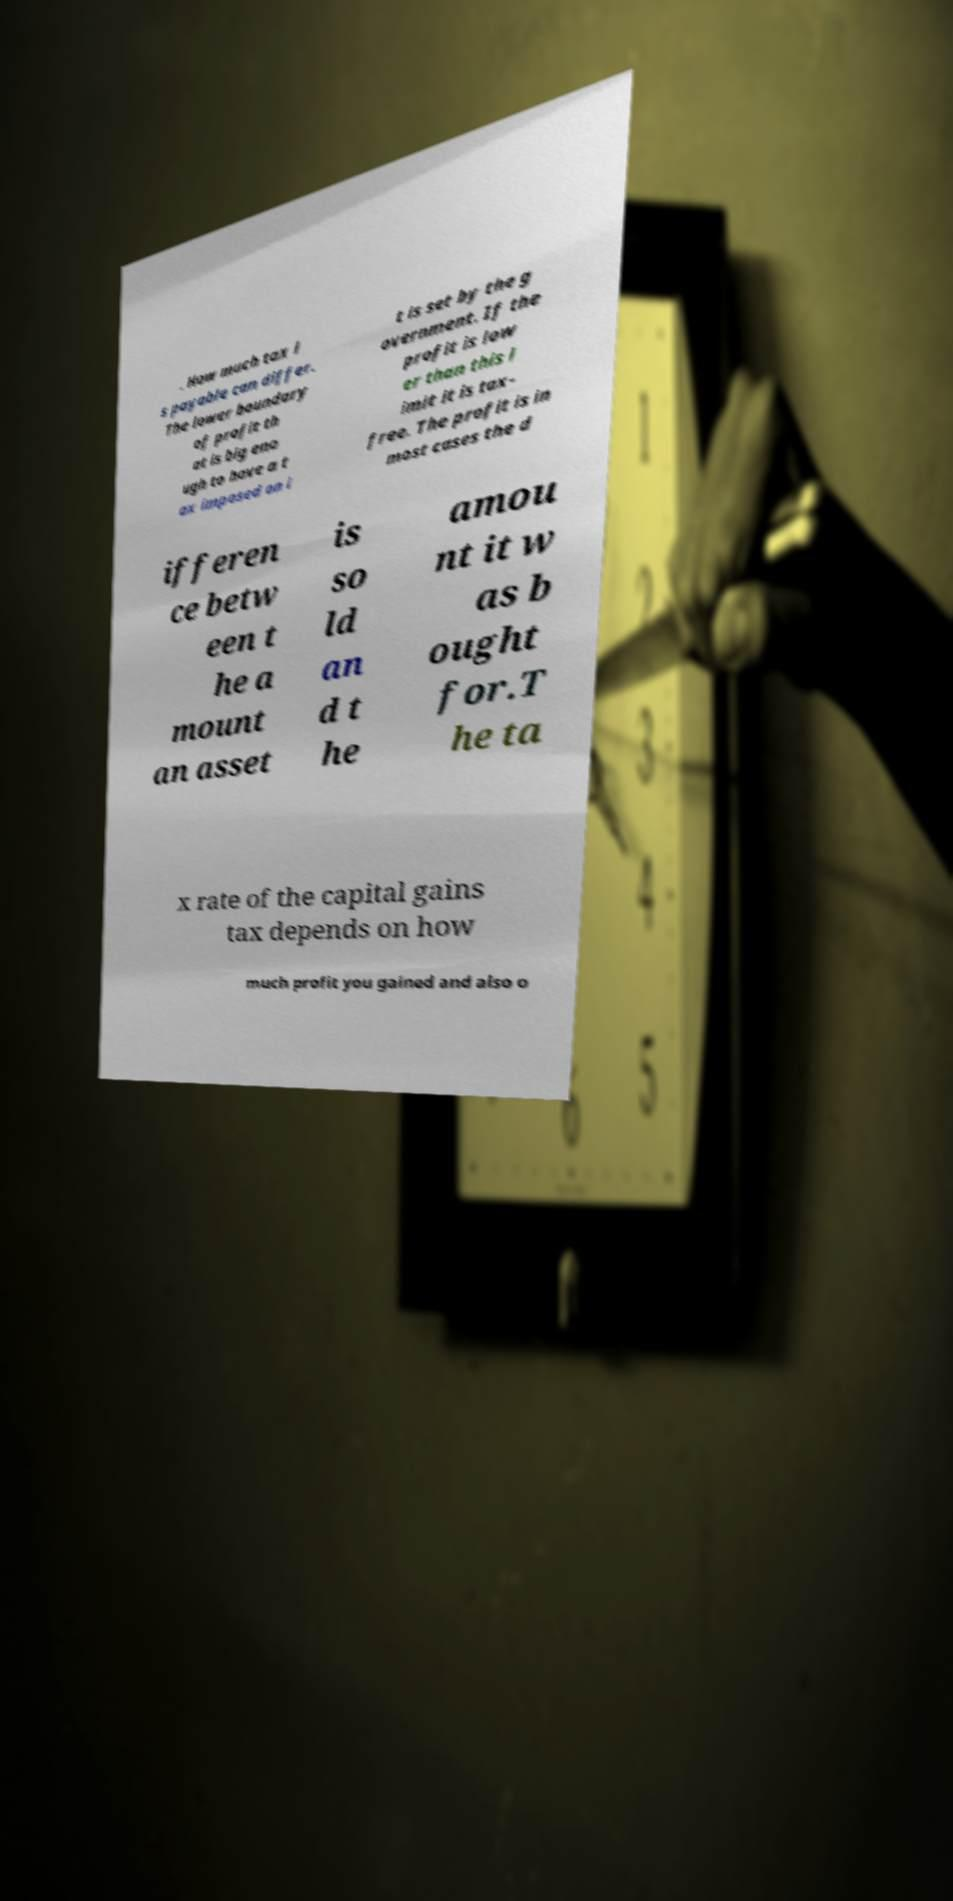Could you assist in decoding the text presented in this image and type it out clearly? . How much tax i s payable can differ. The lower boundary of profit th at is big eno ugh to have a t ax imposed on i t is set by the g overnment. If the profit is low er than this l imit it is tax- free. The profit is in most cases the d ifferen ce betw een t he a mount an asset is so ld an d t he amou nt it w as b ought for.T he ta x rate of the capital gains tax depends on how much profit you gained and also o 